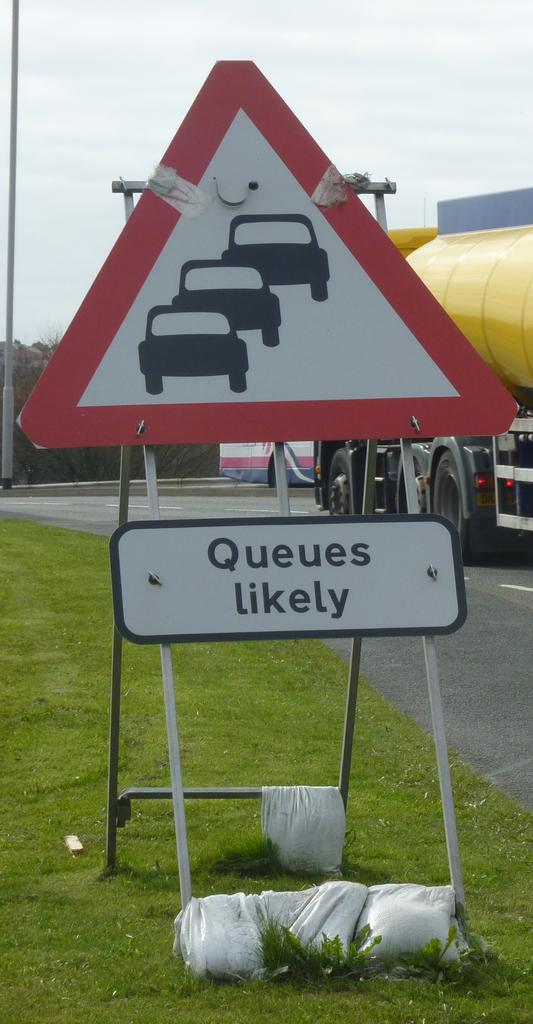<image>
Give a short and clear explanation of the subsequent image. A road sign with the words Queues Likely under it. 